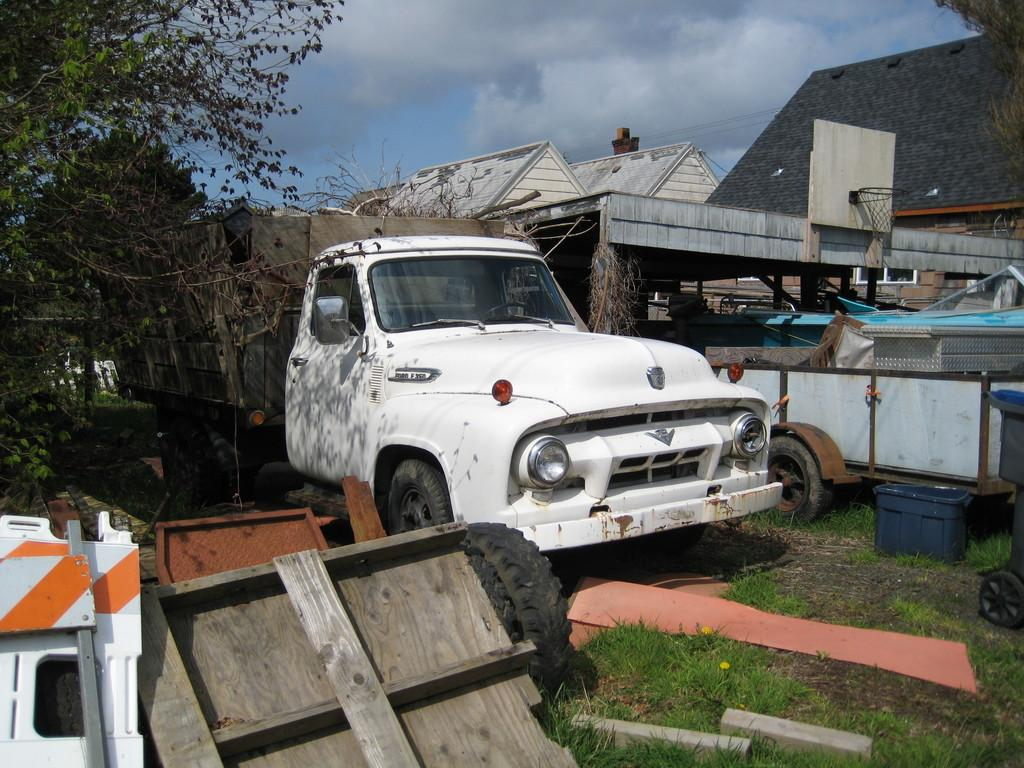What type of vehicle is in the image? There is a white color car in the image. What sports equipment can be seen in the image? There is a basketball net in the image. What type of plant is on the left side of the image? There is a green color plant on the left side of the image. What type of structures are visible in the image? There are homes visible in the image. What is visible at the top of the image? The sky is visible at the top of the image. Where is the pocket located on the car in the image? There is no pocket mentioned or visible on the car in the image. What type of teaching is happening in the image? There is no teaching activity depicted in the image. 